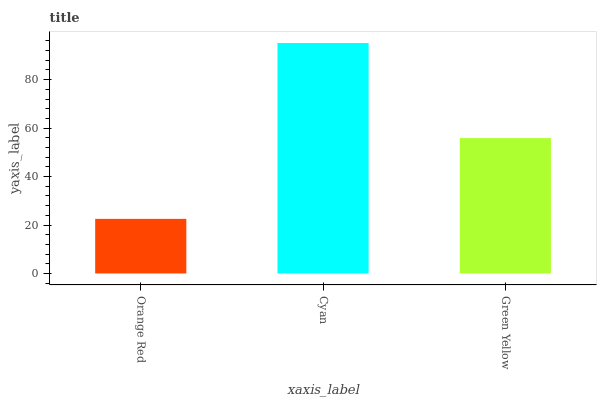Is Orange Red the minimum?
Answer yes or no. Yes. Is Cyan the maximum?
Answer yes or no. Yes. Is Green Yellow the minimum?
Answer yes or no. No. Is Green Yellow the maximum?
Answer yes or no. No. Is Cyan greater than Green Yellow?
Answer yes or no. Yes. Is Green Yellow less than Cyan?
Answer yes or no. Yes. Is Green Yellow greater than Cyan?
Answer yes or no. No. Is Cyan less than Green Yellow?
Answer yes or no. No. Is Green Yellow the high median?
Answer yes or no. Yes. Is Green Yellow the low median?
Answer yes or no. Yes. Is Cyan the high median?
Answer yes or no. No. Is Orange Red the low median?
Answer yes or no. No. 